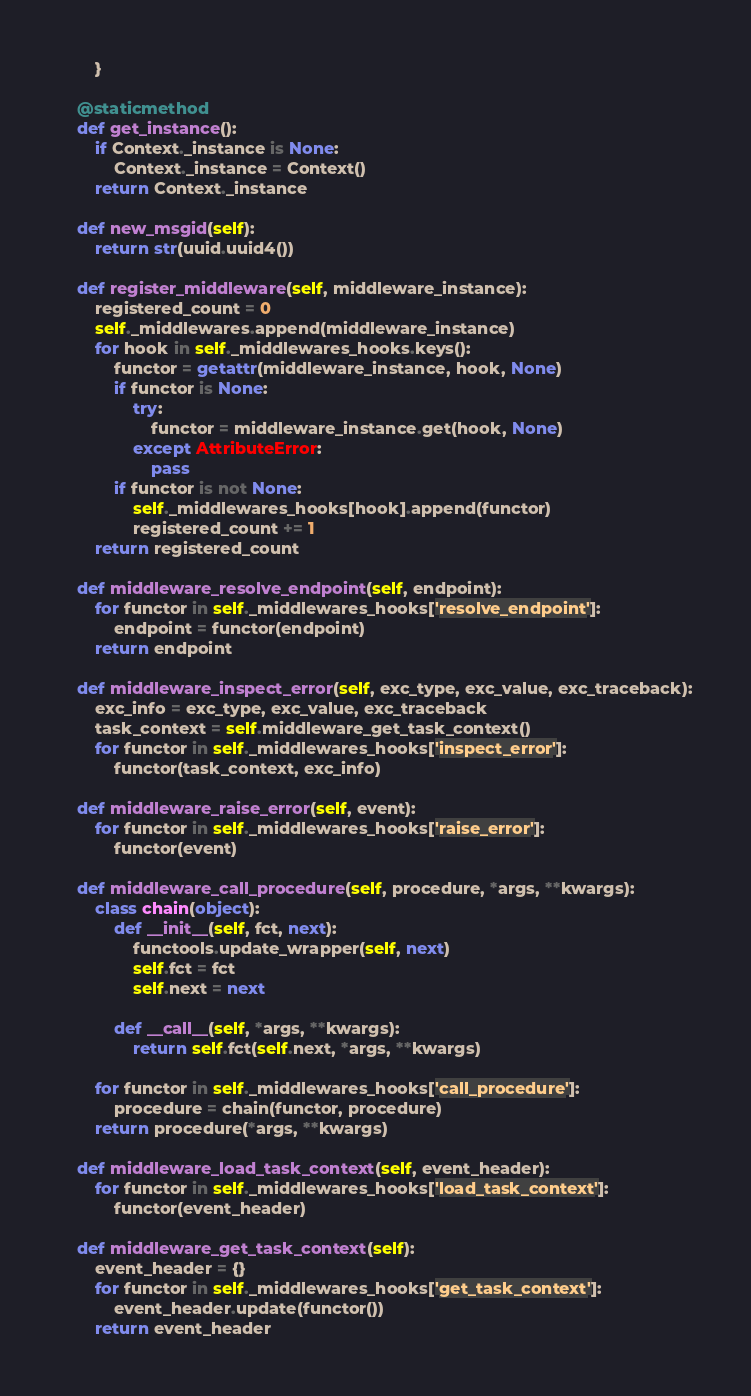Convert code to text. <code><loc_0><loc_0><loc_500><loc_500><_Python_>        }

    @staticmethod
    def get_instance():
        if Context._instance is None:
            Context._instance = Context()
        return Context._instance

    def new_msgid(self):
        return str(uuid.uuid4())

    def register_middleware(self, middleware_instance):
        registered_count = 0
        self._middlewares.append(middleware_instance)
        for hook in self._middlewares_hooks.keys():
            functor = getattr(middleware_instance, hook, None)
            if functor is None:
                try:
                    functor = middleware_instance.get(hook, None)
                except AttributeError:
                    pass
            if functor is not None:
                self._middlewares_hooks[hook].append(functor)
                registered_count += 1
        return registered_count

    def middleware_resolve_endpoint(self, endpoint):
        for functor in self._middlewares_hooks['resolve_endpoint']:
            endpoint = functor(endpoint)
        return endpoint

    def middleware_inspect_error(self, exc_type, exc_value, exc_traceback):
        exc_info = exc_type, exc_value, exc_traceback
        task_context = self.middleware_get_task_context()
        for functor in self._middlewares_hooks['inspect_error']:
            functor(task_context, exc_info)

    def middleware_raise_error(self, event):
        for functor in self._middlewares_hooks['raise_error']:
            functor(event)

    def middleware_call_procedure(self, procedure, *args, **kwargs):
        class chain(object):
            def __init__(self, fct, next):
                functools.update_wrapper(self, next)
                self.fct = fct
                self.next = next

            def __call__(self, *args, **kwargs):
                return self.fct(self.next, *args, **kwargs)

        for functor in self._middlewares_hooks['call_procedure']:
            procedure = chain(functor, procedure)
        return procedure(*args, **kwargs)

    def middleware_load_task_context(self, event_header):
        for functor in self._middlewares_hooks['load_task_context']:
            functor(event_header)

    def middleware_get_task_context(self):
        event_header = {}
        for functor in self._middlewares_hooks['get_task_context']:
            event_header.update(functor())
        return event_header
</code> 